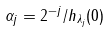<formula> <loc_0><loc_0><loc_500><loc_500>\alpha _ { j } = 2 ^ { - j } / h _ { \lambda _ { j } } ( 0 )</formula> 